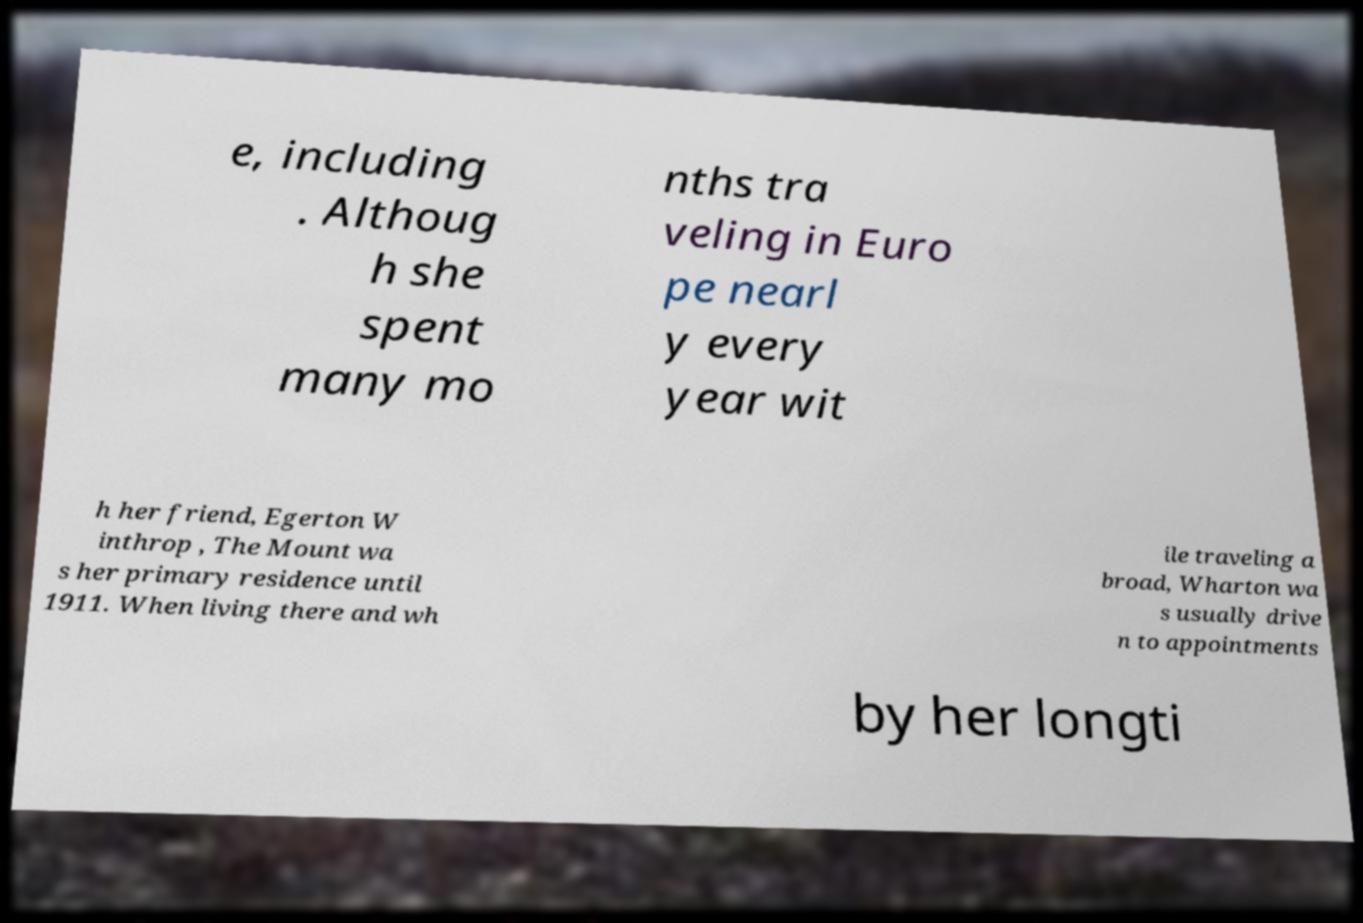I need the written content from this picture converted into text. Can you do that? e, including . Althoug h she spent many mo nths tra veling in Euro pe nearl y every year wit h her friend, Egerton W inthrop , The Mount wa s her primary residence until 1911. When living there and wh ile traveling a broad, Wharton wa s usually drive n to appointments by her longti 